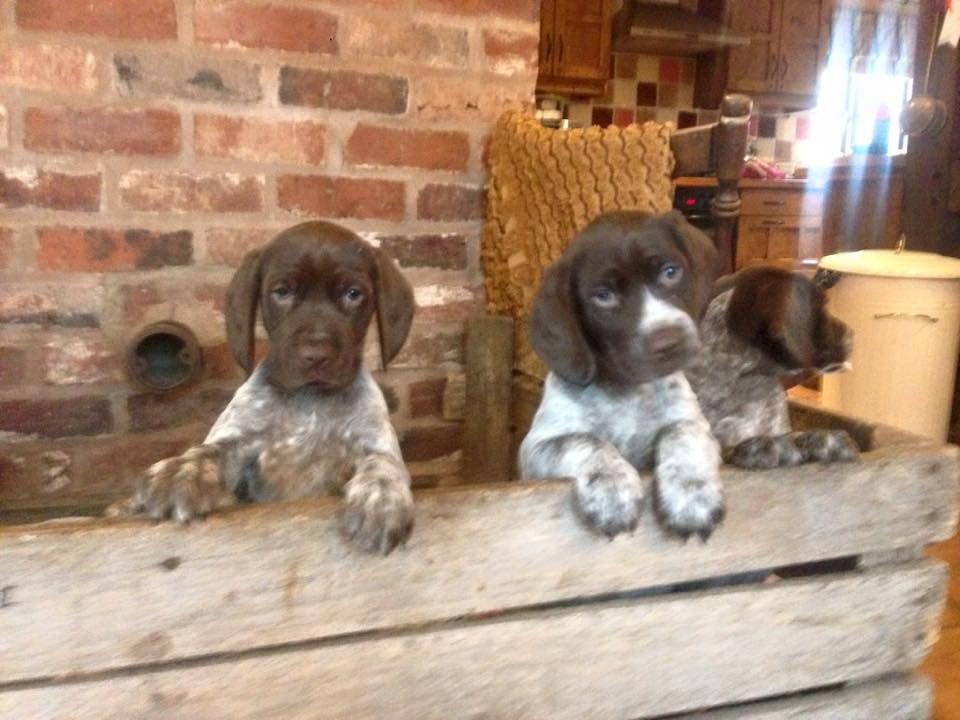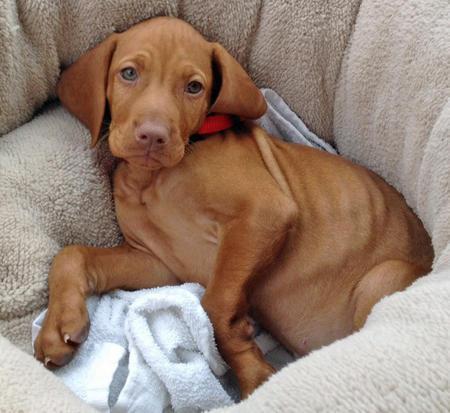The first image is the image on the left, the second image is the image on the right. Analyze the images presented: Is the assertion "The right image contains exactly one dog." valid? Answer yes or no. Yes. The first image is the image on the left, the second image is the image on the right. Considering the images on both sides, is "The combined images include one reddish-brown reclining dog and at least two spaniels with mostly white bodies and darker face markings." valid? Answer yes or no. Yes. 